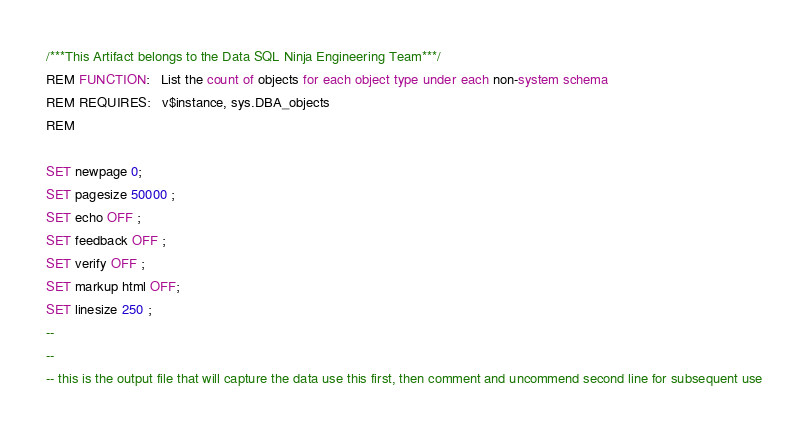<code> <loc_0><loc_0><loc_500><loc_500><_SQL_>/***This Artifact belongs to the Data SQL Ninja Engineering Team***/
REM FUNCTION:   List the count of objects for each object type under each non-system schema
REM REQUIRES:   v$instance, sys.DBA_objects
REM

SET newpage 0;
SET pagesize 50000 ;
SET echo OFF ;
SET feedback OFF ;
SET verify OFF ;
SET markup html OFF;
SET linesize 250 ;
--
--
-- this is the output file that will capture the data use this first, then comment and uncommend second line for subsequent use</code> 